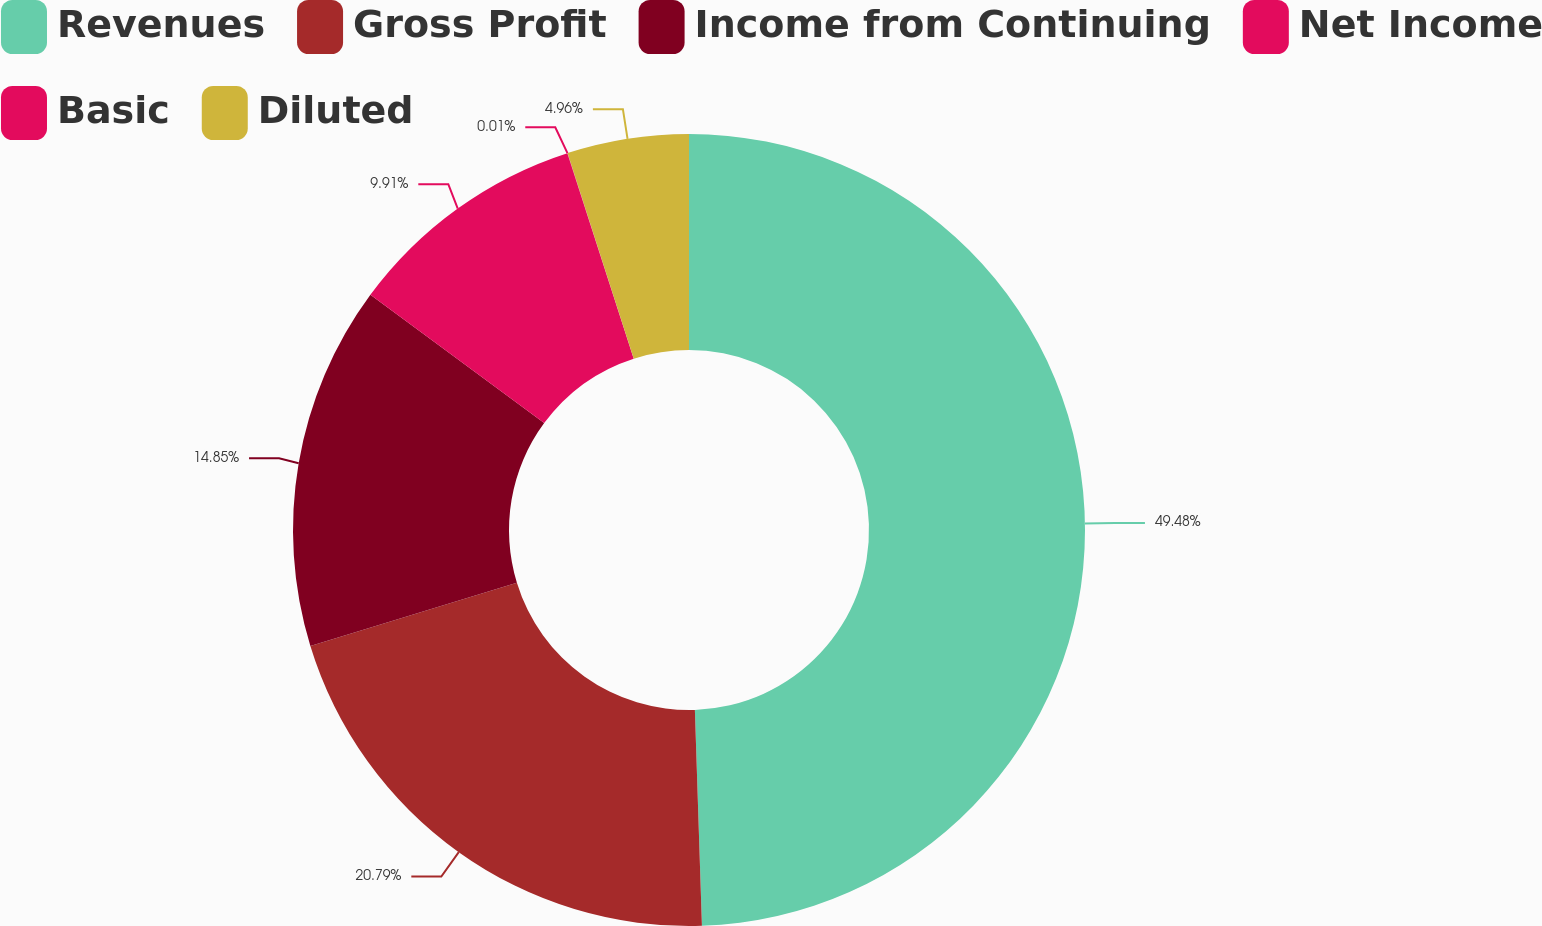<chart> <loc_0><loc_0><loc_500><loc_500><pie_chart><fcel>Revenues<fcel>Gross Profit<fcel>Income from Continuing<fcel>Net Income<fcel>Basic<fcel>Diluted<nl><fcel>49.48%<fcel>20.79%<fcel>14.85%<fcel>9.91%<fcel>0.01%<fcel>4.96%<nl></chart> 